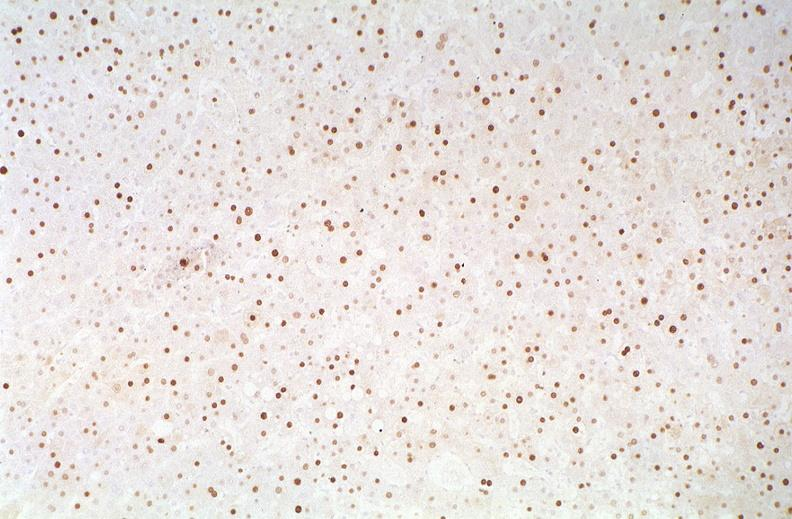s liver present?
Answer the question using a single word or phrase. Yes 